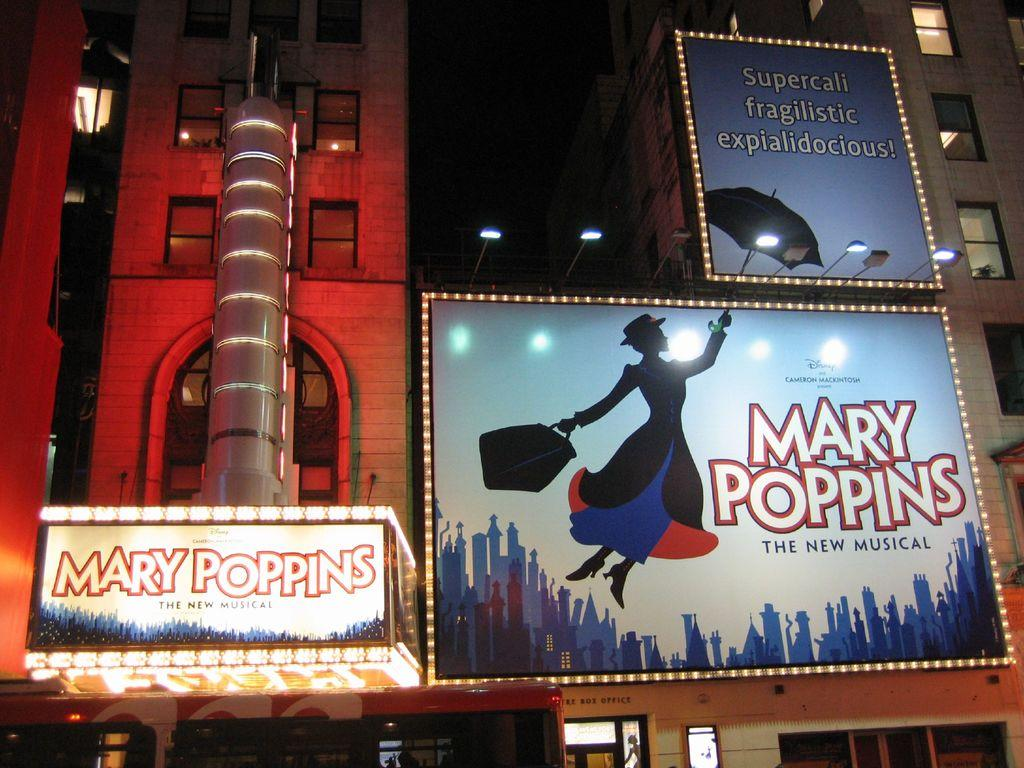Provide a one-sentence caption for the provided image. Marry Poppins musical billboard next to the entrance. 